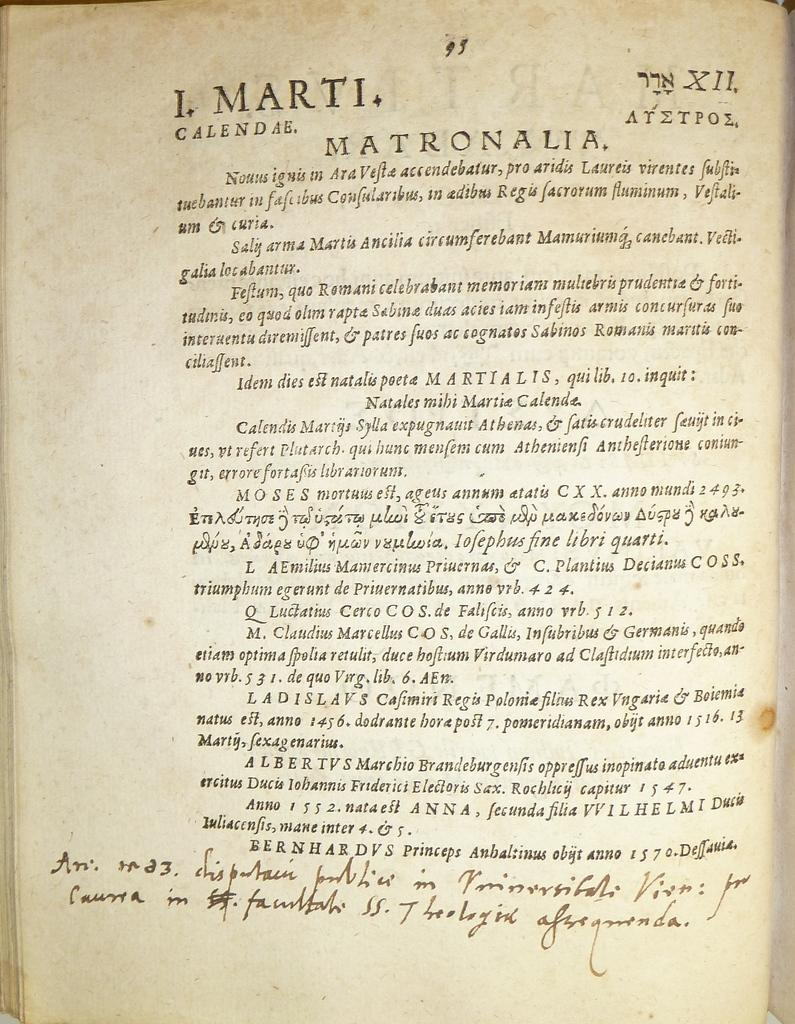<image>
Present a compact description of the photo's key features. Page 93 of a text in a foreign language has some hand written notes. 